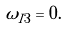<formula> <loc_0><loc_0><loc_500><loc_500>\omega _ { I 3 } = 0 .</formula> 